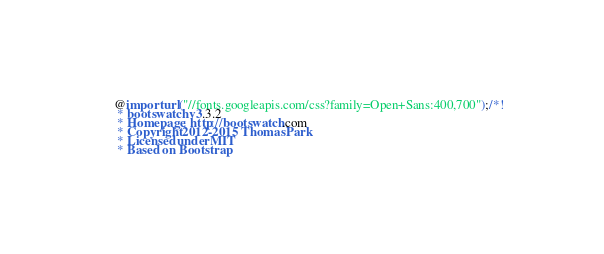Convert code to text. <code><loc_0><loc_0><loc_500><loc_500><_CSS_>@import url("//fonts.googleapis.com/css?family=Open+Sans:400,700");/*!
 * bootswatch v3.3.2
 * Homepage: http://bootswatch.com
 * Copyright 2012-2015 Thomas Park
 * Licensed under MIT
 * Based on Bootstrap</code> 